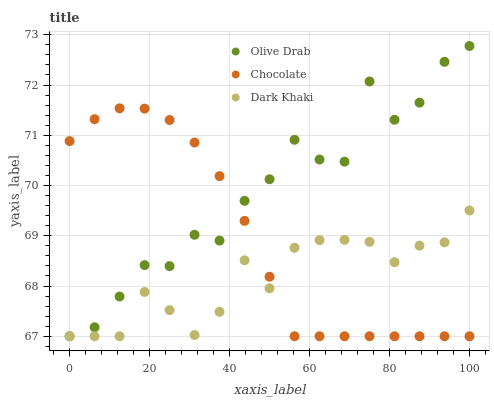Does Dark Khaki have the minimum area under the curve?
Answer yes or no. Yes. Does Olive Drab have the maximum area under the curve?
Answer yes or no. Yes. Does Chocolate have the minimum area under the curve?
Answer yes or no. No. Does Chocolate have the maximum area under the curve?
Answer yes or no. No. Is Chocolate the smoothest?
Answer yes or no. Yes. Is Olive Drab the roughest?
Answer yes or no. Yes. Is Olive Drab the smoothest?
Answer yes or no. No. Is Chocolate the roughest?
Answer yes or no. No. Does Dark Khaki have the lowest value?
Answer yes or no. Yes. Does Olive Drab have the highest value?
Answer yes or no. Yes. Does Chocolate have the highest value?
Answer yes or no. No. Does Dark Khaki intersect Chocolate?
Answer yes or no. Yes. Is Dark Khaki less than Chocolate?
Answer yes or no. No. Is Dark Khaki greater than Chocolate?
Answer yes or no. No. 